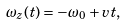Convert formula to latex. <formula><loc_0><loc_0><loc_500><loc_500>\omega _ { z } ( t ) = - \omega _ { 0 } + v t ,</formula> 